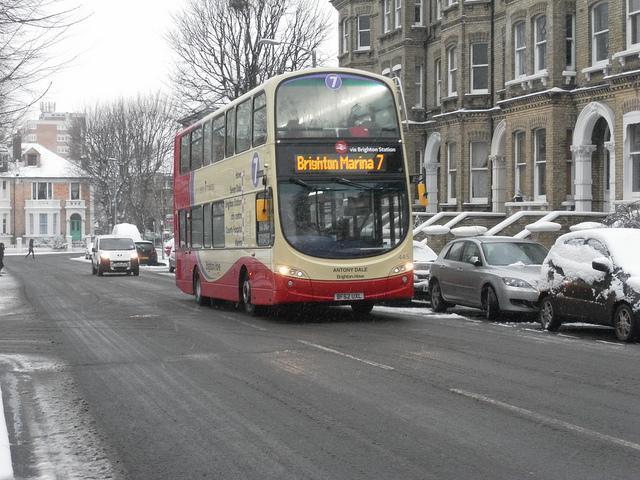How many levels the bus has?
Give a very brief answer. 2. How many cars are there?
Give a very brief answer. 2. 